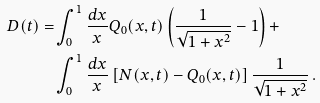Convert formula to latex. <formula><loc_0><loc_0><loc_500><loc_500>D ( t ) = & \int _ { 0 } ^ { 1 } \frac { d x } { x } Q _ { 0 } ( x , t ) \left ( \frac { 1 } { \sqrt { 1 + x ^ { 2 } } } - 1 \right ) + \\ & \int _ { 0 } ^ { 1 } \frac { d x } { x } \left [ N ( x , t ) - Q _ { 0 } ( x , t ) \right ] \frac { 1 } { \sqrt { 1 + x ^ { 2 } } } \, .</formula> 